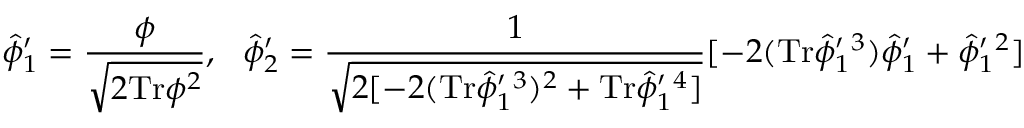<formula> <loc_0><loc_0><loc_500><loc_500>\hat { \phi } _ { 1 } ^ { \prime } = \frac { \phi } { \sqrt { 2 T r \phi ^ { 2 } } } , \quad h a t { \phi } _ { 2 } ^ { \prime } = \frac { 1 } { \sqrt { 2 [ - 2 ( T r \hat { \phi } _ { 1 } ^ { \prime ^ { 3 } ) ^ { 2 } + T r \hat { \phi } _ { 1 } ^ { \prime ^ { 4 } ] } } [ - 2 ( T r \hat { \phi } _ { 1 } ^ { \prime ^ { 3 } ) \hat { \phi } _ { 1 } ^ { \prime } + \hat { \phi } _ { 1 } ^ { \prime ^ { 2 } ]</formula> 